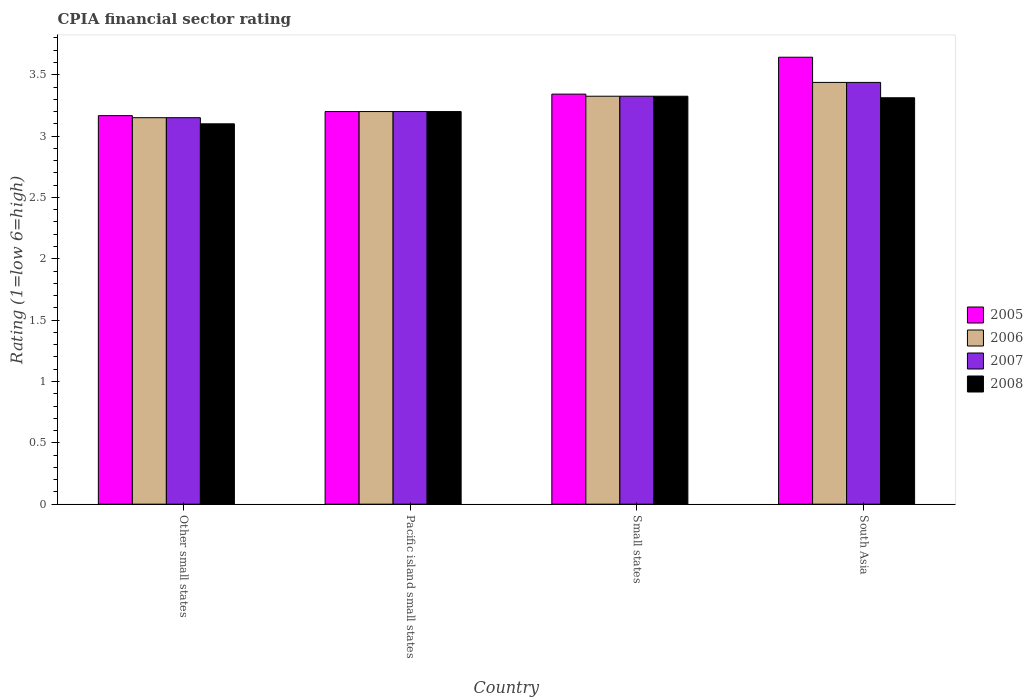How many groups of bars are there?
Your answer should be compact. 4. Are the number of bars on each tick of the X-axis equal?
Give a very brief answer. Yes. How many bars are there on the 1st tick from the left?
Provide a succinct answer. 4. How many bars are there on the 1st tick from the right?
Keep it short and to the point. 4. What is the label of the 4th group of bars from the left?
Provide a short and direct response. South Asia. What is the CPIA rating in 2005 in Other small states?
Ensure brevity in your answer.  3.17. Across all countries, what is the maximum CPIA rating in 2005?
Offer a terse response. 3.64. Across all countries, what is the minimum CPIA rating in 2007?
Provide a succinct answer. 3.15. In which country was the CPIA rating in 2007 minimum?
Make the answer very short. Other small states. What is the total CPIA rating in 2008 in the graph?
Keep it short and to the point. 12.94. What is the difference between the CPIA rating in 2007 in Pacific island small states and that in Small states?
Provide a short and direct response. -0.12. What is the difference between the CPIA rating in 2008 in Other small states and the CPIA rating in 2006 in Small states?
Your answer should be very brief. -0.23. What is the average CPIA rating in 2006 per country?
Your answer should be compact. 3.28. What is the difference between the CPIA rating of/in 2006 and CPIA rating of/in 2008 in Other small states?
Ensure brevity in your answer.  0.05. What is the ratio of the CPIA rating in 2008 in Pacific island small states to that in Small states?
Your answer should be compact. 0.96. Is the CPIA rating in 2007 in Pacific island small states less than that in Small states?
Make the answer very short. Yes. Is the difference between the CPIA rating in 2006 in Pacific island small states and Small states greater than the difference between the CPIA rating in 2008 in Pacific island small states and Small states?
Your response must be concise. No. What is the difference between the highest and the second highest CPIA rating in 2007?
Your answer should be compact. -0.11. What is the difference between the highest and the lowest CPIA rating in 2006?
Your response must be concise. 0.29. In how many countries, is the CPIA rating in 2006 greater than the average CPIA rating in 2006 taken over all countries?
Give a very brief answer. 2. Is it the case that in every country, the sum of the CPIA rating in 2006 and CPIA rating in 2007 is greater than the sum of CPIA rating in 2005 and CPIA rating in 2008?
Ensure brevity in your answer.  No. What does the 3rd bar from the left in Small states represents?
Ensure brevity in your answer.  2007. How many bars are there?
Give a very brief answer. 16. How many countries are there in the graph?
Keep it short and to the point. 4. Where does the legend appear in the graph?
Provide a short and direct response. Center right. How many legend labels are there?
Give a very brief answer. 4. What is the title of the graph?
Your answer should be compact. CPIA financial sector rating. What is the label or title of the X-axis?
Make the answer very short. Country. What is the label or title of the Y-axis?
Your answer should be compact. Rating (1=low 6=high). What is the Rating (1=low 6=high) of 2005 in Other small states?
Your answer should be very brief. 3.17. What is the Rating (1=low 6=high) in 2006 in Other small states?
Keep it short and to the point. 3.15. What is the Rating (1=low 6=high) of 2007 in Other small states?
Offer a terse response. 3.15. What is the Rating (1=low 6=high) in 2005 in Pacific island small states?
Your answer should be compact. 3.2. What is the Rating (1=low 6=high) in 2006 in Pacific island small states?
Keep it short and to the point. 3.2. What is the Rating (1=low 6=high) of 2007 in Pacific island small states?
Offer a very short reply. 3.2. What is the Rating (1=low 6=high) of 2005 in Small states?
Offer a very short reply. 3.34. What is the Rating (1=low 6=high) of 2006 in Small states?
Offer a very short reply. 3.33. What is the Rating (1=low 6=high) in 2007 in Small states?
Your answer should be compact. 3.33. What is the Rating (1=low 6=high) of 2008 in Small states?
Ensure brevity in your answer.  3.33. What is the Rating (1=low 6=high) of 2005 in South Asia?
Offer a very short reply. 3.64. What is the Rating (1=low 6=high) of 2006 in South Asia?
Provide a short and direct response. 3.44. What is the Rating (1=low 6=high) in 2007 in South Asia?
Make the answer very short. 3.44. What is the Rating (1=low 6=high) in 2008 in South Asia?
Keep it short and to the point. 3.31. Across all countries, what is the maximum Rating (1=low 6=high) in 2005?
Provide a short and direct response. 3.64. Across all countries, what is the maximum Rating (1=low 6=high) of 2006?
Give a very brief answer. 3.44. Across all countries, what is the maximum Rating (1=low 6=high) in 2007?
Your response must be concise. 3.44. Across all countries, what is the maximum Rating (1=low 6=high) of 2008?
Give a very brief answer. 3.33. Across all countries, what is the minimum Rating (1=low 6=high) of 2005?
Make the answer very short. 3.17. Across all countries, what is the minimum Rating (1=low 6=high) in 2006?
Offer a very short reply. 3.15. Across all countries, what is the minimum Rating (1=low 6=high) in 2007?
Make the answer very short. 3.15. Across all countries, what is the minimum Rating (1=low 6=high) of 2008?
Your answer should be compact. 3.1. What is the total Rating (1=low 6=high) in 2005 in the graph?
Your answer should be compact. 13.35. What is the total Rating (1=low 6=high) of 2006 in the graph?
Give a very brief answer. 13.11. What is the total Rating (1=low 6=high) of 2007 in the graph?
Offer a terse response. 13.11. What is the total Rating (1=low 6=high) in 2008 in the graph?
Your response must be concise. 12.94. What is the difference between the Rating (1=low 6=high) of 2005 in Other small states and that in Pacific island small states?
Give a very brief answer. -0.03. What is the difference between the Rating (1=low 6=high) of 2006 in Other small states and that in Pacific island small states?
Give a very brief answer. -0.05. What is the difference between the Rating (1=low 6=high) in 2007 in Other small states and that in Pacific island small states?
Provide a short and direct response. -0.05. What is the difference between the Rating (1=low 6=high) in 2005 in Other small states and that in Small states?
Keep it short and to the point. -0.18. What is the difference between the Rating (1=low 6=high) of 2006 in Other small states and that in Small states?
Make the answer very short. -0.17. What is the difference between the Rating (1=low 6=high) in 2007 in Other small states and that in Small states?
Your answer should be very brief. -0.17. What is the difference between the Rating (1=low 6=high) of 2008 in Other small states and that in Small states?
Offer a very short reply. -0.23. What is the difference between the Rating (1=low 6=high) in 2005 in Other small states and that in South Asia?
Provide a succinct answer. -0.48. What is the difference between the Rating (1=low 6=high) of 2006 in Other small states and that in South Asia?
Offer a very short reply. -0.29. What is the difference between the Rating (1=low 6=high) in 2007 in Other small states and that in South Asia?
Provide a succinct answer. -0.29. What is the difference between the Rating (1=low 6=high) of 2008 in Other small states and that in South Asia?
Your answer should be compact. -0.21. What is the difference between the Rating (1=low 6=high) of 2005 in Pacific island small states and that in Small states?
Give a very brief answer. -0.14. What is the difference between the Rating (1=low 6=high) in 2006 in Pacific island small states and that in Small states?
Provide a short and direct response. -0.12. What is the difference between the Rating (1=low 6=high) in 2007 in Pacific island small states and that in Small states?
Your answer should be compact. -0.12. What is the difference between the Rating (1=low 6=high) in 2008 in Pacific island small states and that in Small states?
Keep it short and to the point. -0.12. What is the difference between the Rating (1=low 6=high) of 2005 in Pacific island small states and that in South Asia?
Provide a succinct answer. -0.44. What is the difference between the Rating (1=low 6=high) of 2006 in Pacific island small states and that in South Asia?
Provide a short and direct response. -0.24. What is the difference between the Rating (1=low 6=high) of 2007 in Pacific island small states and that in South Asia?
Offer a terse response. -0.24. What is the difference between the Rating (1=low 6=high) of 2008 in Pacific island small states and that in South Asia?
Give a very brief answer. -0.11. What is the difference between the Rating (1=low 6=high) in 2005 in Small states and that in South Asia?
Your answer should be compact. -0.3. What is the difference between the Rating (1=low 6=high) of 2006 in Small states and that in South Asia?
Provide a short and direct response. -0.11. What is the difference between the Rating (1=low 6=high) in 2007 in Small states and that in South Asia?
Give a very brief answer. -0.11. What is the difference between the Rating (1=low 6=high) in 2008 in Small states and that in South Asia?
Your answer should be compact. 0.01. What is the difference between the Rating (1=low 6=high) of 2005 in Other small states and the Rating (1=low 6=high) of 2006 in Pacific island small states?
Your answer should be compact. -0.03. What is the difference between the Rating (1=low 6=high) of 2005 in Other small states and the Rating (1=low 6=high) of 2007 in Pacific island small states?
Offer a very short reply. -0.03. What is the difference between the Rating (1=low 6=high) of 2005 in Other small states and the Rating (1=low 6=high) of 2008 in Pacific island small states?
Make the answer very short. -0.03. What is the difference between the Rating (1=low 6=high) in 2005 in Other small states and the Rating (1=low 6=high) in 2006 in Small states?
Offer a terse response. -0.16. What is the difference between the Rating (1=low 6=high) of 2005 in Other small states and the Rating (1=low 6=high) of 2007 in Small states?
Offer a terse response. -0.16. What is the difference between the Rating (1=low 6=high) in 2005 in Other small states and the Rating (1=low 6=high) in 2008 in Small states?
Ensure brevity in your answer.  -0.16. What is the difference between the Rating (1=low 6=high) in 2006 in Other small states and the Rating (1=low 6=high) in 2007 in Small states?
Give a very brief answer. -0.17. What is the difference between the Rating (1=low 6=high) in 2006 in Other small states and the Rating (1=low 6=high) in 2008 in Small states?
Your answer should be compact. -0.17. What is the difference between the Rating (1=low 6=high) in 2007 in Other small states and the Rating (1=low 6=high) in 2008 in Small states?
Your answer should be compact. -0.17. What is the difference between the Rating (1=low 6=high) in 2005 in Other small states and the Rating (1=low 6=high) in 2006 in South Asia?
Ensure brevity in your answer.  -0.27. What is the difference between the Rating (1=low 6=high) in 2005 in Other small states and the Rating (1=low 6=high) in 2007 in South Asia?
Make the answer very short. -0.27. What is the difference between the Rating (1=low 6=high) in 2005 in Other small states and the Rating (1=low 6=high) in 2008 in South Asia?
Ensure brevity in your answer.  -0.15. What is the difference between the Rating (1=low 6=high) in 2006 in Other small states and the Rating (1=low 6=high) in 2007 in South Asia?
Give a very brief answer. -0.29. What is the difference between the Rating (1=low 6=high) of 2006 in Other small states and the Rating (1=low 6=high) of 2008 in South Asia?
Offer a very short reply. -0.16. What is the difference between the Rating (1=low 6=high) in 2007 in Other small states and the Rating (1=low 6=high) in 2008 in South Asia?
Provide a succinct answer. -0.16. What is the difference between the Rating (1=low 6=high) in 2005 in Pacific island small states and the Rating (1=low 6=high) in 2006 in Small states?
Give a very brief answer. -0.12. What is the difference between the Rating (1=low 6=high) of 2005 in Pacific island small states and the Rating (1=low 6=high) of 2007 in Small states?
Your response must be concise. -0.12. What is the difference between the Rating (1=low 6=high) in 2005 in Pacific island small states and the Rating (1=low 6=high) in 2008 in Small states?
Give a very brief answer. -0.12. What is the difference between the Rating (1=low 6=high) of 2006 in Pacific island small states and the Rating (1=low 6=high) of 2007 in Small states?
Provide a short and direct response. -0.12. What is the difference between the Rating (1=low 6=high) of 2006 in Pacific island small states and the Rating (1=low 6=high) of 2008 in Small states?
Your response must be concise. -0.12. What is the difference between the Rating (1=low 6=high) in 2007 in Pacific island small states and the Rating (1=low 6=high) in 2008 in Small states?
Give a very brief answer. -0.12. What is the difference between the Rating (1=low 6=high) of 2005 in Pacific island small states and the Rating (1=low 6=high) of 2006 in South Asia?
Offer a terse response. -0.24. What is the difference between the Rating (1=low 6=high) of 2005 in Pacific island small states and the Rating (1=low 6=high) of 2007 in South Asia?
Keep it short and to the point. -0.24. What is the difference between the Rating (1=low 6=high) in 2005 in Pacific island small states and the Rating (1=low 6=high) in 2008 in South Asia?
Your answer should be very brief. -0.11. What is the difference between the Rating (1=low 6=high) in 2006 in Pacific island small states and the Rating (1=low 6=high) in 2007 in South Asia?
Your answer should be very brief. -0.24. What is the difference between the Rating (1=low 6=high) in 2006 in Pacific island small states and the Rating (1=low 6=high) in 2008 in South Asia?
Your answer should be compact. -0.11. What is the difference between the Rating (1=low 6=high) in 2007 in Pacific island small states and the Rating (1=low 6=high) in 2008 in South Asia?
Give a very brief answer. -0.11. What is the difference between the Rating (1=low 6=high) in 2005 in Small states and the Rating (1=low 6=high) in 2006 in South Asia?
Provide a short and direct response. -0.1. What is the difference between the Rating (1=low 6=high) in 2005 in Small states and the Rating (1=low 6=high) in 2007 in South Asia?
Provide a short and direct response. -0.1. What is the difference between the Rating (1=low 6=high) in 2005 in Small states and the Rating (1=low 6=high) in 2008 in South Asia?
Give a very brief answer. 0.03. What is the difference between the Rating (1=low 6=high) in 2006 in Small states and the Rating (1=low 6=high) in 2007 in South Asia?
Offer a terse response. -0.11. What is the difference between the Rating (1=low 6=high) of 2006 in Small states and the Rating (1=low 6=high) of 2008 in South Asia?
Provide a short and direct response. 0.01. What is the difference between the Rating (1=low 6=high) of 2007 in Small states and the Rating (1=low 6=high) of 2008 in South Asia?
Your answer should be very brief. 0.01. What is the average Rating (1=low 6=high) in 2005 per country?
Provide a succinct answer. 3.34. What is the average Rating (1=low 6=high) in 2006 per country?
Your answer should be compact. 3.28. What is the average Rating (1=low 6=high) of 2007 per country?
Ensure brevity in your answer.  3.28. What is the average Rating (1=low 6=high) of 2008 per country?
Your answer should be very brief. 3.23. What is the difference between the Rating (1=low 6=high) of 2005 and Rating (1=low 6=high) of 2006 in Other small states?
Offer a terse response. 0.02. What is the difference between the Rating (1=low 6=high) of 2005 and Rating (1=low 6=high) of 2007 in Other small states?
Ensure brevity in your answer.  0.02. What is the difference between the Rating (1=low 6=high) of 2005 and Rating (1=low 6=high) of 2008 in Other small states?
Give a very brief answer. 0.07. What is the difference between the Rating (1=low 6=high) in 2006 and Rating (1=low 6=high) in 2007 in Other small states?
Ensure brevity in your answer.  0. What is the difference between the Rating (1=low 6=high) in 2006 and Rating (1=low 6=high) in 2008 in Other small states?
Your response must be concise. 0.05. What is the difference between the Rating (1=low 6=high) in 2007 and Rating (1=low 6=high) in 2008 in Pacific island small states?
Provide a succinct answer. 0. What is the difference between the Rating (1=low 6=high) of 2005 and Rating (1=low 6=high) of 2006 in Small states?
Give a very brief answer. 0.02. What is the difference between the Rating (1=low 6=high) in 2005 and Rating (1=low 6=high) in 2007 in Small states?
Keep it short and to the point. 0.02. What is the difference between the Rating (1=low 6=high) in 2005 and Rating (1=low 6=high) in 2008 in Small states?
Your answer should be compact. 0.02. What is the difference between the Rating (1=low 6=high) in 2006 and Rating (1=low 6=high) in 2007 in Small states?
Your answer should be very brief. 0. What is the difference between the Rating (1=low 6=high) of 2006 and Rating (1=low 6=high) of 2008 in Small states?
Provide a succinct answer. 0. What is the difference between the Rating (1=low 6=high) in 2007 and Rating (1=low 6=high) in 2008 in Small states?
Keep it short and to the point. 0. What is the difference between the Rating (1=low 6=high) of 2005 and Rating (1=low 6=high) of 2006 in South Asia?
Make the answer very short. 0.21. What is the difference between the Rating (1=low 6=high) in 2005 and Rating (1=low 6=high) in 2007 in South Asia?
Ensure brevity in your answer.  0.21. What is the difference between the Rating (1=low 6=high) in 2005 and Rating (1=low 6=high) in 2008 in South Asia?
Offer a very short reply. 0.33. What is the ratio of the Rating (1=low 6=high) in 2005 in Other small states to that in Pacific island small states?
Provide a succinct answer. 0.99. What is the ratio of the Rating (1=low 6=high) of 2006 in Other small states to that in Pacific island small states?
Offer a terse response. 0.98. What is the ratio of the Rating (1=low 6=high) in 2007 in Other small states to that in Pacific island small states?
Your answer should be compact. 0.98. What is the ratio of the Rating (1=low 6=high) in 2008 in Other small states to that in Pacific island small states?
Ensure brevity in your answer.  0.97. What is the ratio of the Rating (1=low 6=high) of 2005 in Other small states to that in Small states?
Offer a terse response. 0.95. What is the ratio of the Rating (1=low 6=high) in 2007 in Other small states to that in Small states?
Ensure brevity in your answer.  0.95. What is the ratio of the Rating (1=low 6=high) of 2008 in Other small states to that in Small states?
Offer a very short reply. 0.93. What is the ratio of the Rating (1=low 6=high) of 2005 in Other small states to that in South Asia?
Offer a very short reply. 0.87. What is the ratio of the Rating (1=low 6=high) of 2006 in Other small states to that in South Asia?
Your answer should be very brief. 0.92. What is the ratio of the Rating (1=low 6=high) in 2007 in Other small states to that in South Asia?
Your response must be concise. 0.92. What is the ratio of the Rating (1=low 6=high) of 2008 in Other small states to that in South Asia?
Provide a succinct answer. 0.94. What is the ratio of the Rating (1=low 6=high) of 2005 in Pacific island small states to that in Small states?
Keep it short and to the point. 0.96. What is the ratio of the Rating (1=low 6=high) of 2006 in Pacific island small states to that in Small states?
Ensure brevity in your answer.  0.96. What is the ratio of the Rating (1=low 6=high) of 2007 in Pacific island small states to that in Small states?
Provide a short and direct response. 0.96. What is the ratio of the Rating (1=low 6=high) of 2008 in Pacific island small states to that in Small states?
Your answer should be compact. 0.96. What is the ratio of the Rating (1=low 6=high) of 2005 in Pacific island small states to that in South Asia?
Offer a very short reply. 0.88. What is the ratio of the Rating (1=low 6=high) of 2006 in Pacific island small states to that in South Asia?
Make the answer very short. 0.93. What is the ratio of the Rating (1=low 6=high) of 2007 in Pacific island small states to that in South Asia?
Provide a short and direct response. 0.93. What is the ratio of the Rating (1=low 6=high) in 2008 in Pacific island small states to that in South Asia?
Offer a terse response. 0.97. What is the ratio of the Rating (1=low 6=high) of 2005 in Small states to that in South Asia?
Your answer should be compact. 0.92. What is the ratio of the Rating (1=low 6=high) in 2006 in Small states to that in South Asia?
Your answer should be compact. 0.97. What is the ratio of the Rating (1=low 6=high) of 2007 in Small states to that in South Asia?
Ensure brevity in your answer.  0.97. What is the ratio of the Rating (1=low 6=high) in 2008 in Small states to that in South Asia?
Offer a very short reply. 1. What is the difference between the highest and the second highest Rating (1=low 6=high) in 2005?
Offer a very short reply. 0.3. What is the difference between the highest and the second highest Rating (1=low 6=high) in 2006?
Make the answer very short. 0.11. What is the difference between the highest and the second highest Rating (1=low 6=high) in 2007?
Keep it short and to the point. 0.11. What is the difference between the highest and the second highest Rating (1=low 6=high) in 2008?
Your answer should be compact. 0.01. What is the difference between the highest and the lowest Rating (1=low 6=high) in 2005?
Keep it short and to the point. 0.48. What is the difference between the highest and the lowest Rating (1=low 6=high) of 2006?
Give a very brief answer. 0.29. What is the difference between the highest and the lowest Rating (1=low 6=high) of 2007?
Keep it short and to the point. 0.29. What is the difference between the highest and the lowest Rating (1=low 6=high) in 2008?
Keep it short and to the point. 0.23. 